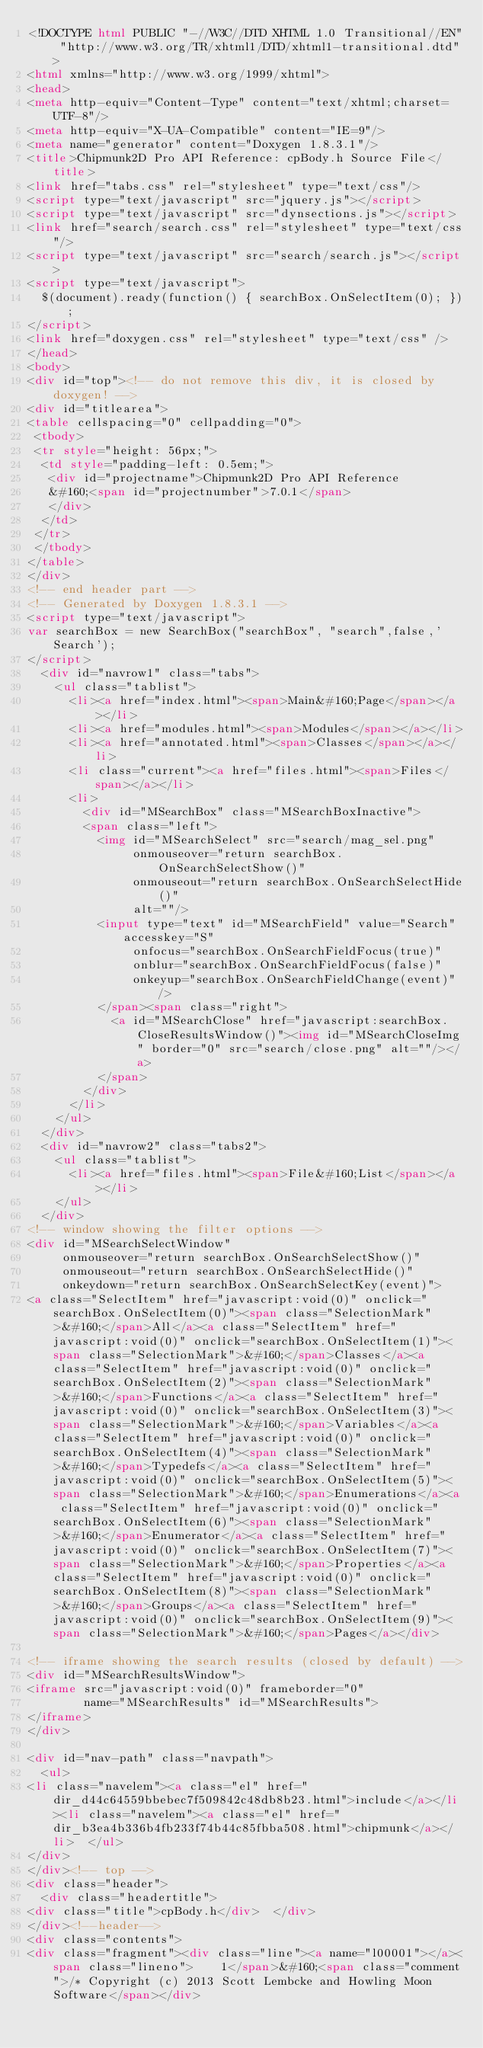Convert code to text. <code><loc_0><loc_0><loc_500><loc_500><_HTML_><!DOCTYPE html PUBLIC "-//W3C//DTD XHTML 1.0 Transitional//EN" "http://www.w3.org/TR/xhtml1/DTD/xhtml1-transitional.dtd">
<html xmlns="http://www.w3.org/1999/xhtml">
<head>
<meta http-equiv="Content-Type" content="text/xhtml;charset=UTF-8"/>
<meta http-equiv="X-UA-Compatible" content="IE=9"/>
<meta name="generator" content="Doxygen 1.8.3.1"/>
<title>Chipmunk2D Pro API Reference: cpBody.h Source File</title>
<link href="tabs.css" rel="stylesheet" type="text/css"/>
<script type="text/javascript" src="jquery.js"></script>
<script type="text/javascript" src="dynsections.js"></script>
<link href="search/search.css" rel="stylesheet" type="text/css"/>
<script type="text/javascript" src="search/search.js"></script>
<script type="text/javascript">
  $(document).ready(function() { searchBox.OnSelectItem(0); });
</script>
<link href="doxygen.css" rel="stylesheet" type="text/css" />
</head>
<body>
<div id="top"><!-- do not remove this div, it is closed by doxygen! -->
<div id="titlearea">
<table cellspacing="0" cellpadding="0">
 <tbody>
 <tr style="height: 56px;">
  <td style="padding-left: 0.5em;">
   <div id="projectname">Chipmunk2D Pro API Reference
   &#160;<span id="projectnumber">7.0.1</span>
   </div>
  </td>
 </tr>
 </tbody>
</table>
</div>
<!-- end header part -->
<!-- Generated by Doxygen 1.8.3.1 -->
<script type="text/javascript">
var searchBox = new SearchBox("searchBox", "search",false,'Search');
</script>
  <div id="navrow1" class="tabs">
    <ul class="tablist">
      <li><a href="index.html"><span>Main&#160;Page</span></a></li>
      <li><a href="modules.html"><span>Modules</span></a></li>
      <li><a href="annotated.html"><span>Classes</span></a></li>
      <li class="current"><a href="files.html"><span>Files</span></a></li>
      <li>
        <div id="MSearchBox" class="MSearchBoxInactive">
        <span class="left">
          <img id="MSearchSelect" src="search/mag_sel.png"
               onmouseover="return searchBox.OnSearchSelectShow()"
               onmouseout="return searchBox.OnSearchSelectHide()"
               alt=""/>
          <input type="text" id="MSearchField" value="Search" accesskey="S"
               onfocus="searchBox.OnSearchFieldFocus(true)" 
               onblur="searchBox.OnSearchFieldFocus(false)" 
               onkeyup="searchBox.OnSearchFieldChange(event)"/>
          </span><span class="right">
            <a id="MSearchClose" href="javascript:searchBox.CloseResultsWindow()"><img id="MSearchCloseImg" border="0" src="search/close.png" alt=""/></a>
          </span>
        </div>
      </li>
    </ul>
  </div>
  <div id="navrow2" class="tabs2">
    <ul class="tablist">
      <li><a href="files.html"><span>File&#160;List</span></a></li>
    </ul>
  </div>
<!-- window showing the filter options -->
<div id="MSearchSelectWindow"
     onmouseover="return searchBox.OnSearchSelectShow()"
     onmouseout="return searchBox.OnSearchSelectHide()"
     onkeydown="return searchBox.OnSearchSelectKey(event)">
<a class="SelectItem" href="javascript:void(0)" onclick="searchBox.OnSelectItem(0)"><span class="SelectionMark">&#160;</span>All</a><a class="SelectItem" href="javascript:void(0)" onclick="searchBox.OnSelectItem(1)"><span class="SelectionMark">&#160;</span>Classes</a><a class="SelectItem" href="javascript:void(0)" onclick="searchBox.OnSelectItem(2)"><span class="SelectionMark">&#160;</span>Functions</a><a class="SelectItem" href="javascript:void(0)" onclick="searchBox.OnSelectItem(3)"><span class="SelectionMark">&#160;</span>Variables</a><a class="SelectItem" href="javascript:void(0)" onclick="searchBox.OnSelectItem(4)"><span class="SelectionMark">&#160;</span>Typedefs</a><a class="SelectItem" href="javascript:void(0)" onclick="searchBox.OnSelectItem(5)"><span class="SelectionMark">&#160;</span>Enumerations</a><a class="SelectItem" href="javascript:void(0)" onclick="searchBox.OnSelectItem(6)"><span class="SelectionMark">&#160;</span>Enumerator</a><a class="SelectItem" href="javascript:void(0)" onclick="searchBox.OnSelectItem(7)"><span class="SelectionMark">&#160;</span>Properties</a><a class="SelectItem" href="javascript:void(0)" onclick="searchBox.OnSelectItem(8)"><span class="SelectionMark">&#160;</span>Groups</a><a class="SelectItem" href="javascript:void(0)" onclick="searchBox.OnSelectItem(9)"><span class="SelectionMark">&#160;</span>Pages</a></div>

<!-- iframe showing the search results (closed by default) -->
<div id="MSearchResultsWindow">
<iframe src="javascript:void(0)" frameborder="0" 
        name="MSearchResults" id="MSearchResults">
</iframe>
</div>

<div id="nav-path" class="navpath">
  <ul>
<li class="navelem"><a class="el" href="dir_d44c64559bbebec7f509842c48db8b23.html">include</a></li><li class="navelem"><a class="el" href="dir_b3ea4b336b4fb233f74b44c85fbba508.html">chipmunk</a></li>  </ul>
</div>
</div><!-- top -->
<div class="header">
  <div class="headertitle">
<div class="title">cpBody.h</div>  </div>
</div><!--header-->
<div class="contents">
<div class="fragment"><div class="line"><a name="l00001"></a><span class="lineno">    1</span>&#160;<span class="comment">/* Copyright (c) 2013 Scott Lembcke and Howling Moon Software</span></div></code> 